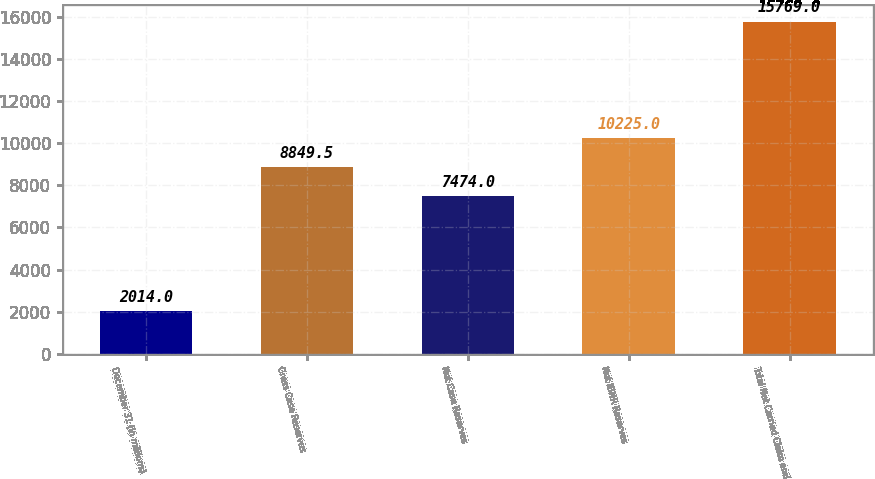<chart> <loc_0><loc_0><loc_500><loc_500><bar_chart><fcel>December 31 (In millions)<fcel>Gross Case Reserves<fcel>Net Case Reserves<fcel>Net IBNR Reserves<fcel>Total Net Carried Claim and<nl><fcel>2014<fcel>8849.5<fcel>7474<fcel>10225<fcel>15769<nl></chart> 